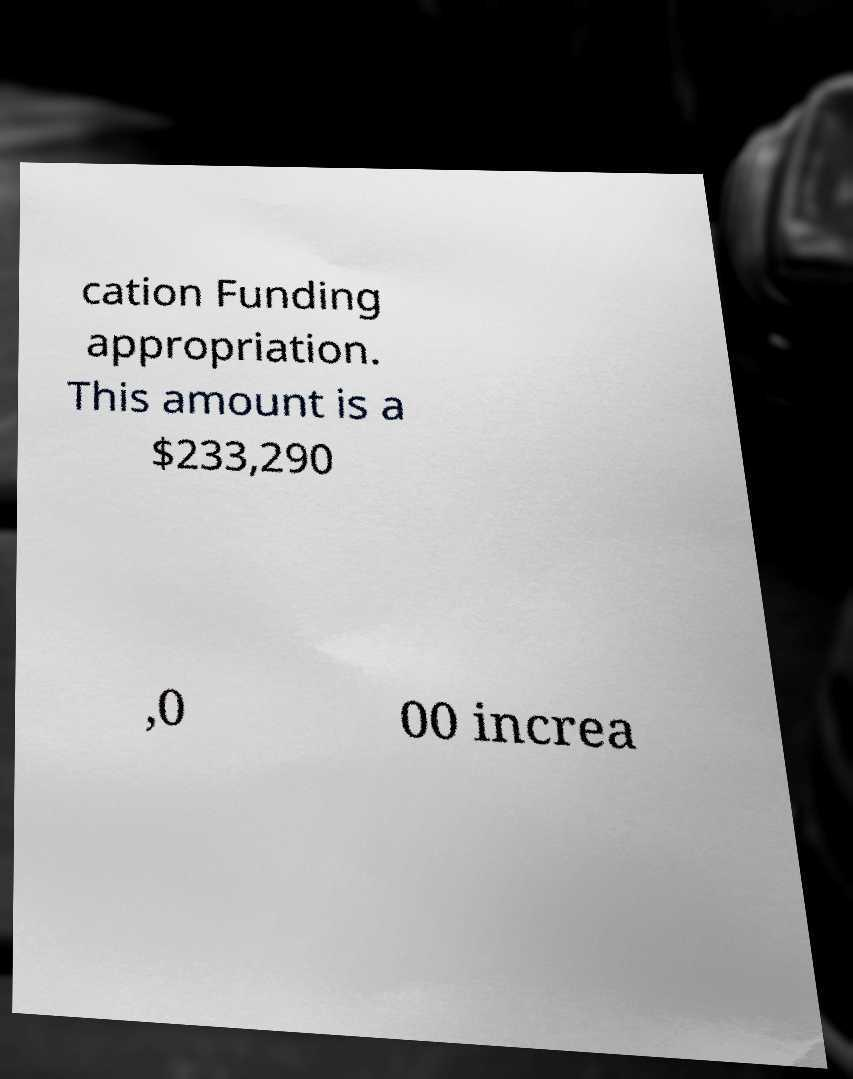Can you read and provide the text displayed in the image?This photo seems to have some interesting text. Can you extract and type it out for me? cation Funding appropriation. This amount is a $233,290 ,0 00 increa 